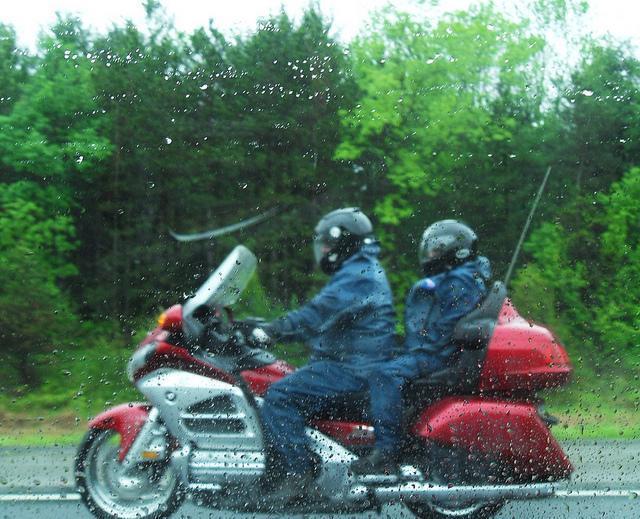How many people are in the photo?
Give a very brief answer. 2. How many cows are standing up?
Give a very brief answer. 0. 